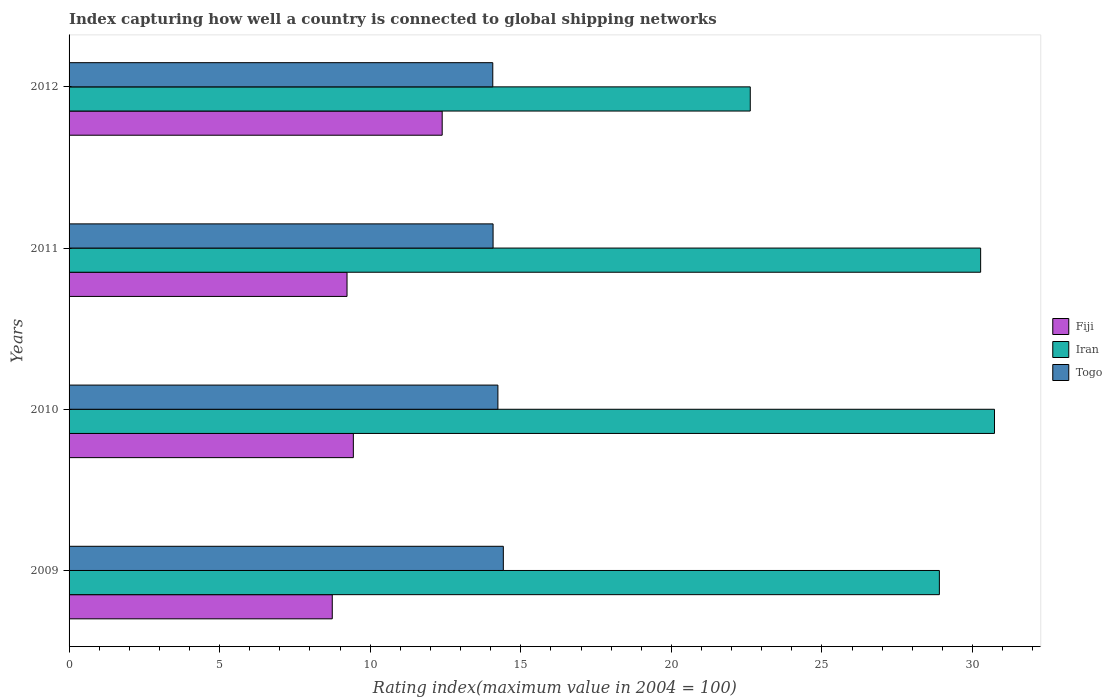How many different coloured bars are there?
Your response must be concise. 3. How many bars are there on the 1st tick from the top?
Provide a short and direct response. 3. What is the label of the 1st group of bars from the top?
Ensure brevity in your answer.  2012. What is the rating index in Fiji in 2010?
Offer a very short reply. 9.44. Across all years, what is the maximum rating index in Iran?
Make the answer very short. 30.73. Across all years, what is the minimum rating index in Iran?
Make the answer very short. 22.62. In which year was the rating index in Togo minimum?
Your response must be concise. 2012. What is the total rating index in Fiji in the graph?
Offer a very short reply. 39.8. What is the difference between the rating index in Iran in 2010 and that in 2012?
Provide a succinct answer. 8.11. What is the average rating index in Iran per year?
Your answer should be very brief. 28.13. In the year 2011, what is the difference between the rating index in Togo and rating index in Iran?
Give a very brief answer. -16.19. In how many years, is the rating index in Iran greater than 24 ?
Keep it short and to the point. 3. What is the ratio of the rating index in Togo in 2011 to that in 2012?
Your answer should be compact. 1. Is the difference between the rating index in Togo in 2010 and 2012 greater than the difference between the rating index in Iran in 2010 and 2012?
Provide a short and direct response. No. What is the difference between the highest and the second highest rating index in Togo?
Make the answer very short. 0.18. What is the difference between the highest and the lowest rating index in Fiji?
Offer a very short reply. 3.65. In how many years, is the rating index in Fiji greater than the average rating index in Fiji taken over all years?
Provide a succinct answer. 1. Is the sum of the rating index in Iran in 2010 and 2011 greater than the maximum rating index in Fiji across all years?
Make the answer very short. Yes. What does the 1st bar from the top in 2012 represents?
Keep it short and to the point. Togo. What does the 1st bar from the bottom in 2009 represents?
Offer a terse response. Fiji. Is it the case that in every year, the sum of the rating index in Iran and rating index in Fiji is greater than the rating index in Togo?
Your answer should be very brief. Yes. How many bars are there?
Provide a short and direct response. 12. Are all the bars in the graph horizontal?
Give a very brief answer. Yes. How many years are there in the graph?
Give a very brief answer. 4. Are the values on the major ticks of X-axis written in scientific E-notation?
Provide a short and direct response. No. Does the graph contain any zero values?
Your answer should be very brief. No. Where does the legend appear in the graph?
Ensure brevity in your answer.  Center right. How many legend labels are there?
Give a very brief answer. 3. How are the legend labels stacked?
Offer a very short reply. Vertical. What is the title of the graph?
Keep it short and to the point. Index capturing how well a country is connected to global shipping networks. What is the label or title of the X-axis?
Ensure brevity in your answer.  Rating index(maximum value in 2004 = 100). What is the Rating index(maximum value in 2004 = 100) of Fiji in 2009?
Make the answer very short. 8.74. What is the Rating index(maximum value in 2004 = 100) of Iran in 2009?
Make the answer very short. 28.9. What is the Rating index(maximum value in 2004 = 100) of Togo in 2009?
Ensure brevity in your answer.  14.42. What is the Rating index(maximum value in 2004 = 100) in Fiji in 2010?
Offer a very short reply. 9.44. What is the Rating index(maximum value in 2004 = 100) of Iran in 2010?
Ensure brevity in your answer.  30.73. What is the Rating index(maximum value in 2004 = 100) of Togo in 2010?
Your response must be concise. 14.24. What is the Rating index(maximum value in 2004 = 100) in Fiji in 2011?
Make the answer very short. 9.23. What is the Rating index(maximum value in 2004 = 100) of Iran in 2011?
Provide a succinct answer. 30.27. What is the Rating index(maximum value in 2004 = 100) in Togo in 2011?
Make the answer very short. 14.08. What is the Rating index(maximum value in 2004 = 100) in Fiji in 2012?
Provide a short and direct response. 12.39. What is the Rating index(maximum value in 2004 = 100) of Iran in 2012?
Your answer should be compact. 22.62. What is the Rating index(maximum value in 2004 = 100) in Togo in 2012?
Ensure brevity in your answer.  14.07. Across all years, what is the maximum Rating index(maximum value in 2004 = 100) of Fiji?
Make the answer very short. 12.39. Across all years, what is the maximum Rating index(maximum value in 2004 = 100) in Iran?
Your answer should be very brief. 30.73. Across all years, what is the maximum Rating index(maximum value in 2004 = 100) in Togo?
Your answer should be very brief. 14.42. Across all years, what is the minimum Rating index(maximum value in 2004 = 100) in Fiji?
Your response must be concise. 8.74. Across all years, what is the minimum Rating index(maximum value in 2004 = 100) of Iran?
Provide a short and direct response. 22.62. Across all years, what is the minimum Rating index(maximum value in 2004 = 100) in Togo?
Your answer should be very brief. 14.07. What is the total Rating index(maximum value in 2004 = 100) in Fiji in the graph?
Provide a short and direct response. 39.8. What is the total Rating index(maximum value in 2004 = 100) of Iran in the graph?
Your response must be concise. 112.52. What is the total Rating index(maximum value in 2004 = 100) in Togo in the graph?
Offer a terse response. 56.81. What is the difference between the Rating index(maximum value in 2004 = 100) of Iran in 2009 and that in 2010?
Offer a terse response. -1.83. What is the difference between the Rating index(maximum value in 2004 = 100) of Togo in 2009 and that in 2010?
Make the answer very short. 0.18. What is the difference between the Rating index(maximum value in 2004 = 100) of Fiji in 2009 and that in 2011?
Offer a very short reply. -0.49. What is the difference between the Rating index(maximum value in 2004 = 100) of Iran in 2009 and that in 2011?
Keep it short and to the point. -1.37. What is the difference between the Rating index(maximum value in 2004 = 100) in Togo in 2009 and that in 2011?
Give a very brief answer. 0.34. What is the difference between the Rating index(maximum value in 2004 = 100) of Fiji in 2009 and that in 2012?
Offer a very short reply. -3.65. What is the difference between the Rating index(maximum value in 2004 = 100) of Iran in 2009 and that in 2012?
Keep it short and to the point. 6.28. What is the difference between the Rating index(maximum value in 2004 = 100) in Togo in 2009 and that in 2012?
Give a very brief answer. 0.35. What is the difference between the Rating index(maximum value in 2004 = 100) in Fiji in 2010 and that in 2011?
Your answer should be compact. 0.21. What is the difference between the Rating index(maximum value in 2004 = 100) in Iran in 2010 and that in 2011?
Your response must be concise. 0.46. What is the difference between the Rating index(maximum value in 2004 = 100) in Togo in 2010 and that in 2011?
Offer a terse response. 0.16. What is the difference between the Rating index(maximum value in 2004 = 100) in Fiji in 2010 and that in 2012?
Your response must be concise. -2.95. What is the difference between the Rating index(maximum value in 2004 = 100) of Iran in 2010 and that in 2012?
Keep it short and to the point. 8.11. What is the difference between the Rating index(maximum value in 2004 = 100) of Togo in 2010 and that in 2012?
Provide a succinct answer. 0.17. What is the difference between the Rating index(maximum value in 2004 = 100) in Fiji in 2011 and that in 2012?
Offer a very short reply. -3.16. What is the difference between the Rating index(maximum value in 2004 = 100) in Iran in 2011 and that in 2012?
Give a very brief answer. 7.65. What is the difference between the Rating index(maximum value in 2004 = 100) of Togo in 2011 and that in 2012?
Provide a succinct answer. 0.01. What is the difference between the Rating index(maximum value in 2004 = 100) in Fiji in 2009 and the Rating index(maximum value in 2004 = 100) in Iran in 2010?
Your answer should be very brief. -21.99. What is the difference between the Rating index(maximum value in 2004 = 100) of Iran in 2009 and the Rating index(maximum value in 2004 = 100) of Togo in 2010?
Ensure brevity in your answer.  14.66. What is the difference between the Rating index(maximum value in 2004 = 100) in Fiji in 2009 and the Rating index(maximum value in 2004 = 100) in Iran in 2011?
Offer a terse response. -21.53. What is the difference between the Rating index(maximum value in 2004 = 100) of Fiji in 2009 and the Rating index(maximum value in 2004 = 100) of Togo in 2011?
Your answer should be very brief. -5.34. What is the difference between the Rating index(maximum value in 2004 = 100) of Iran in 2009 and the Rating index(maximum value in 2004 = 100) of Togo in 2011?
Give a very brief answer. 14.82. What is the difference between the Rating index(maximum value in 2004 = 100) of Fiji in 2009 and the Rating index(maximum value in 2004 = 100) of Iran in 2012?
Your response must be concise. -13.88. What is the difference between the Rating index(maximum value in 2004 = 100) of Fiji in 2009 and the Rating index(maximum value in 2004 = 100) of Togo in 2012?
Ensure brevity in your answer.  -5.33. What is the difference between the Rating index(maximum value in 2004 = 100) of Iran in 2009 and the Rating index(maximum value in 2004 = 100) of Togo in 2012?
Provide a succinct answer. 14.83. What is the difference between the Rating index(maximum value in 2004 = 100) of Fiji in 2010 and the Rating index(maximum value in 2004 = 100) of Iran in 2011?
Provide a short and direct response. -20.83. What is the difference between the Rating index(maximum value in 2004 = 100) in Fiji in 2010 and the Rating index(maximum value in 2004 = 100) in Togo in 2011?
Provide a succinct answer. -4.64. What is the difference between the Rating index(maximum value in 2004 = 100) of Iran in 2010 and the Rating index(maximum value in 2004 = 100) of Togo in 2011?
Give a very brief answer. 16.65. What is the difference between the Rating index(maximum value in 2004 = 100) in Fiji in 2010 and the Rating index(maximum value in 2004 = 100) in Iran in 2012?
Provide a succinct answer. -13.18. What is the difference between the Rating index(maximum value in 2004 = 100) in Fiji in 2010 and the Rating index(maximum value in 2004 = 100) in Togo in 2012?
Ensure brevity in your answer.  -4.63. What is the difference between the Rating index(maximum value in 2004 = 100) of Iran in 2010 and the Rating index(maximum value in 2004 = 100) of Togo in 2012?
Your answer should be compact. 16.66. What is the difference between the Rating index(maximum value in 2004 = 100) in Fiji in 2011 and the Rating index(maximum value in 2004 = 100) in Iran in 2012?
Your answer should be compact. -13.39. What is the difference between the Rating index(maximum value in 2004 = 100) of Fiji in 2011 and the Rating index(maximum value in 2004 = 100) of Togo in 2012?
Offer a terse response. -4.84. What is the difference between the Rating index(maximum value in 2004 = 100) of Iran in 2011 and the Rating index(maximum value in 2004 = 100) of Togo in 2012?
Give a very brief answer. 16.2. What is the average Rating index(maximum value in 2004 = 100) in Fiji per year?
Your response must be concise. 9.95. What is the average Rating index(maximum value in 2004 = 100) of Iran per year?
Ensure brevity in your answer.  28.13. What is the average Rating index(maximum value in 2004 = 100) in Togo per year?
Offer a terse response. 14.2. In the year 2009, what is the difference between the Rating index(maximum value in 2004 = 100) of Fiji and Rating index(maximum value in 2004 = 100) of Iran?
Offer a terse response. -20.16. In the year 2009, what is the difference between the Rating index(maximum value in 2004 = 100) in Fiji and Rating index(maximum value in 2004 = 100) in Togo?
Keep it short and to the point. -5.68. In the year 2009, what is the difference between the Rating index(maximum value in 2004 = 100) in Iran and Rating index(maximum value in 2004 = 100) in Togo?
Offer a very short reply. 14.48. In the year 2010, what is the difference between the Rating index(maximum value in 2004 = 100) in Fiji and Rating index(maximum value in 2004 = 100) in Iran?
Make the answer very short. -21.29. In the year 2010, what is the difference between the Rating index(maximum value in 2004 = 100) of Iran and Rating index(maximum value in 2004 = 100) of Togo?
Your answer should be very brief. 16.49. In the year 2011, what is the difference between the Rating index(maximum value in 2004 = 100) of Fiji and Rating index(maximum value in 2004 = 100) of Iran?
Give a very brief answer. -21.04. In the year 2011, what is the difference between the Rating index(maximum value in 2004 = 100) of Fiji and Rating index(maximum value in 2004 = 100) of Togo?
Keep it short and to the point. -4.85. In the year 2011, what is the difference between the Rating index(maximum value in 2004 = 100) in Iran and Rating index(maximum value in 2004 = 100) in Togo?
Provide a short and direct response. 16.19. In the year 2012, what is the difference between the Rating index(maximum value in 2004 = 100) of Fiji and Rating index(maximum value in 2004 = 100) of Iran?
Your response must be concise. -10.23. In the year 2012, what is the difference between the Rating index(maximum value in 2004 = 100) in Fiji and Rating index(maximum value in 2004 = 100) in Togo?
Your answer should be compact. -1.68. In the year 2012, what is the difference between the Rating index(maximum value in 2004 = 100) of Iran and Rating index(maximum value in 2004 = 100) of Togo?
Make the answer very short. 8.55. What is the ratio of the Rating index(maximum value in 2004 = 100) of Fiji in 2009 to that in 2010?
Your response must be concise. 0.93. What is the ratio of the Rating index(maximum value in 2004 = 100) of Iran in 2009 to that in 2010?
Your answer should be very brief. 0.94. What is the ratio of the Rating index(maximum value in 2004 = 100) in Togo in 2009 to that in 2010?
Offer a terse response. 1.01. What is the ratio of the Rating index(maximum value in 2004 = 100) in Fiji in 2009 to that in 2011?
Your answer should be compact. 0.95. What is the ratio of the Rating index(maximum value in 2004 = 100) of Iran in 2009 to that in 2011?
Offer a terse response. 0.95. What is the ratio of the Rating index(maximum value in 2004 = 100) of Togo in 2009 to that in 2011?
Your answer should be very brief. 1.02. What is the ratio of the Rating index(maximum value in 2004 = 100) in Fiji in 2009 to that in 2012?
Your response must be concise. 0.71. What is the ratio of the Rating index(maximum value in 2004 = 100) of Iran in 2009 to that in 2012?
Provide a succinct answer. 1.28. What is the ratio of the Rating index(maximum value in 2004 = 100) of Togo in 2009 to that in 2012?
Your answer should be very brief. 1.02. What is the ratio of the Rating index(maximum value in 2004 = 100) in Fiji in 2010 to that in 2011?
Give a very brief answer. 1.02. What is the ratio of the Rating index(maximum value in 2004 = 100) in Iran in 2010 to that in 2011?
Provide a succinct answer. 1.02. What is the ratio of the Rating index(maximum value in 2004 = 100) of Togo in 2010 to that in 2011?
Keep it short and to the point. 1.01. What is the ratio of the Rating index(maximum value in 2004 = 100) in Fiji in 2010 to that in 2012?
Offer a very short reply. 0.76. What is the ratio of the Rating index(maximum value in 2004 = 100) of Iran in 2010 to that in 2012?
Keep it short and to the point. 1.36. What is the ratio of the Rating index(maximum value in 2004 = 100) in Togo in 2010 to that in 2012?
Offer a terse response. 1.01. What is the ratio of the Rating index(maximum value in 2004 = 100) of Fiji in 2011 to that in 2012?
Provide a short and direct response. 0.74. What is the ratio of the Rating index(maximum value in 2004 = 100) of Iran in 2011 to that in 2012?
Your answer should be compact. 1.34. What is the ratio of the Rating index(maximum value in 2004 = 100) in Togo in 2011 to that in 2012?
Provide a short and direct response. 1. What is the difference between the highest and the second highest Rating index(maximum value in 2004 = 100) of Fiji?
Provide a short and direct response. 2.95. What is the difference between the highest and the second highest Rating index(maximum value in 2004 = 100) of Iran?
Offer a very short reply. 0.46. What is the difference between the highest and the second highest Rating index(maximum value in 2004 = 100) in Togo?
Make the answer very short. 0.18. What is the difference between the highest and the lowest Rating index(maximum value in 2004 = 100) of Fiji?
Make the answer very short. 3.65. What is the difference between the highest and the lowest Rating index(maximum value in 2004 = 100) of Iran?
Your response must be concise. 8.11. 